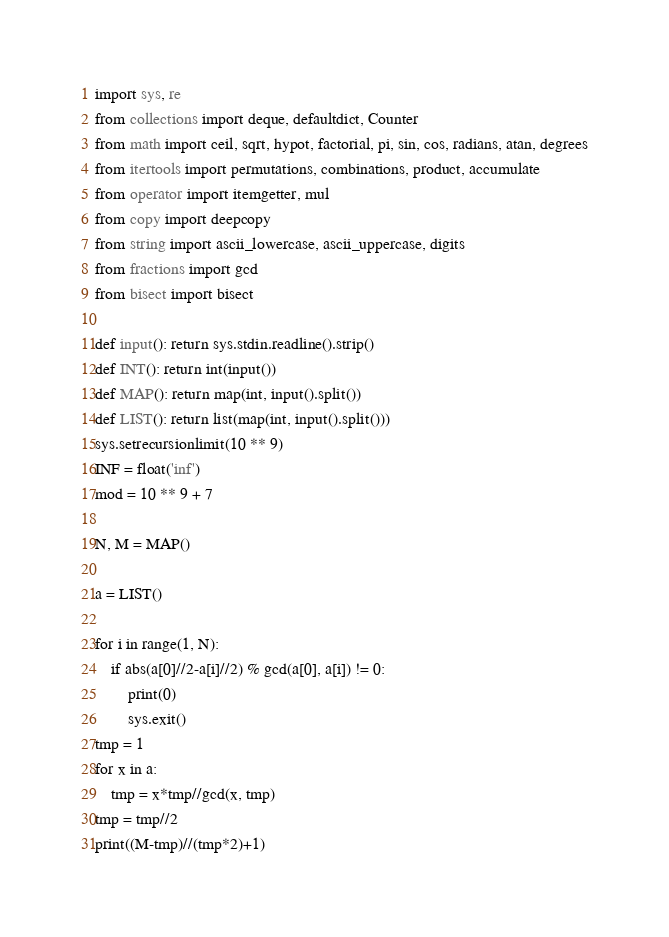<code> <loc_0><loc_0><loc_500><loc_500><_Python_>import sys, re
from collections import deque, defaultdict, Counter
from math import ceil, sqrt, hypot, factorial, pi, sin, cos, radians, atan, degrees
from itertools import permutations, combinations, product, accumulate
from operator import itemgetter, mul
from copy import deepcopy
from string import ascii_lowercase, ascii_uppercase, digits
from fractions import gcd
from bisect import bisect

def input(): return sys.stdin.readline().strip()
def INT(): return int(input())
def MAP(): return map(int, input().split())
def LIST(): return list(map(int, input().split()))
sys.setrecursionlimit(10 ** 9)
INF = float('inf')
mod = 10 ** 9 + 7

N, M = MAP()

a = LIST()

for i in range(1, N):
	if abs(a[0]//2-a[i]//2) % gcd(a[0], a[i]) != 0:
		print(0)
		sys.exit()
tmp = 1
for x in a:
	tmp = x*tmp//gcd(x, tmp)
tmp = tmp//2
print((M-tmp)//(tmp*2)+1)
</code> 